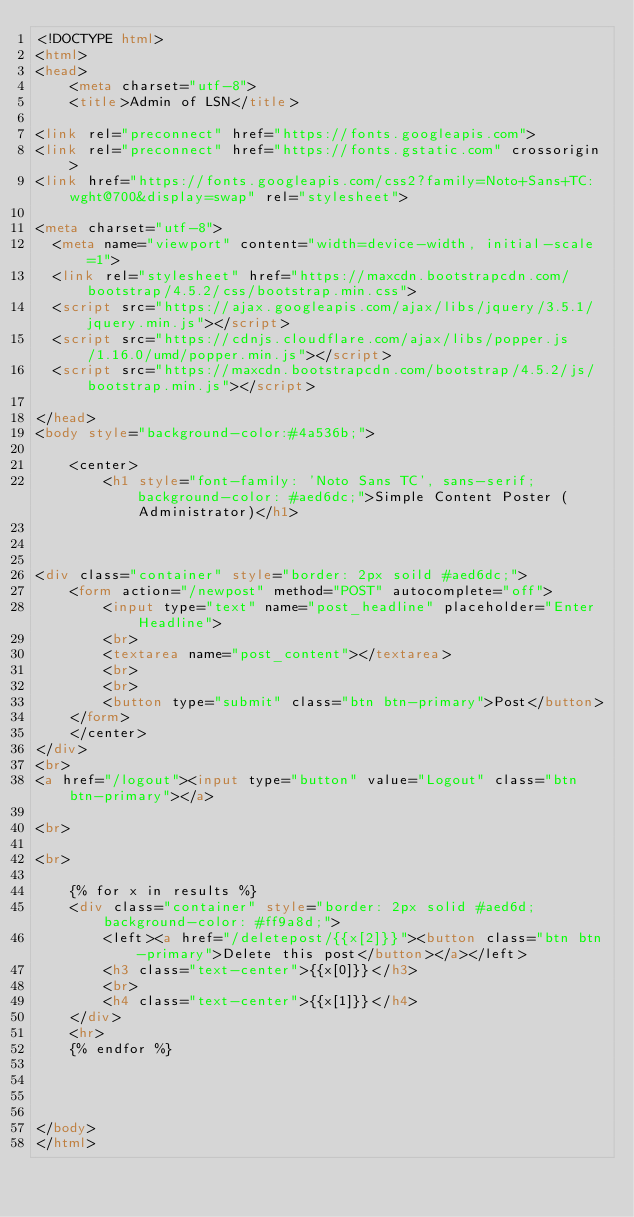Convert code to text. <code><loc_0><loc_0><loc_500><loc_500><_HTML_><!DOCTYPE html>
<html>
<head>
	<meta charset="utf-8">
	<title>Admin of LSN</title>

<link rel="preconnect" href="https://fonts.googleapis.com">
<link rel="preconnect" href="https://fonts.gstatic.com" crossorigin>
<link href="https://fonts.googleapis.com/css2?family=Noto+Sans+TC:wght@700&display=swap" rel="stylesheet"> 

<meta charset="utf-8">
  <meta name="viewport" content="width=device-width, initial-scale=1">
  <link rel="stylesheet" href="https://maxcdn.bootstrapcdn.com/bootstrap/4.5.2/css/bootstrap.min.css">
  <script src="https://ajax.googleapis.com/ajax/libs/jquery/3.5.1/jquery.min.js"></script>
  <script src="https://cdnjs.cloudflare.com/ajax/libs/popper.js/1.16.0/umd/popper.min.js"></script>
  <script src="https://maxcdn.bootstrapcdn.com/bootstrap/4.5.2/js/bootstrap.min.js"></script>

</head>
<body style="background-color:#4a536b;">

	<center>
		<h1 style="font-family: 'Noto Sans TC', sans-serif; background-color: #aed6dc;">Simple Content Poster (Administrator)</h1>



<div class="container" style="border: 2px soild #aed6dc;">
	<form action="/newpost" method="POST" autocomplete="off">
		<input type="text" name="post_headline" placeholder="Enter Headline">
		<br>
		<textarea name="post_content"></textarea>
		<br>
		<br>
		<button type="submit" class="btn btn-primary">Post</button>
	</form>
	</center>
</div>
<br>
<a href="/logout"><input type="button" value="Logout" class="btn btn-primary"></a>

<br>

<br>

	{% for x in results %}
	<div class="container" style="border: 2px solid #aed6d; background-color: #ff9a8d;">
		<left><a href="/deletepost/{{x[2]}}"><button class="btn btn-primary">Delete this post</button></a></left>
		<h3 class="text-center">{{x[0]}}</h3>
		<br>
		<h4 class="text-center">{{x[1]}}</h4>
	</div>
	<hr>
	{% endfor %}




</body>
</html>

</code> 